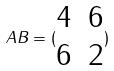<formula> <loc_0><loc_0><loc_500><loc_500>A B = ( \begin{matrix} 4 & 6 \\ 6 & 2 \end{matrix} )</formula> 